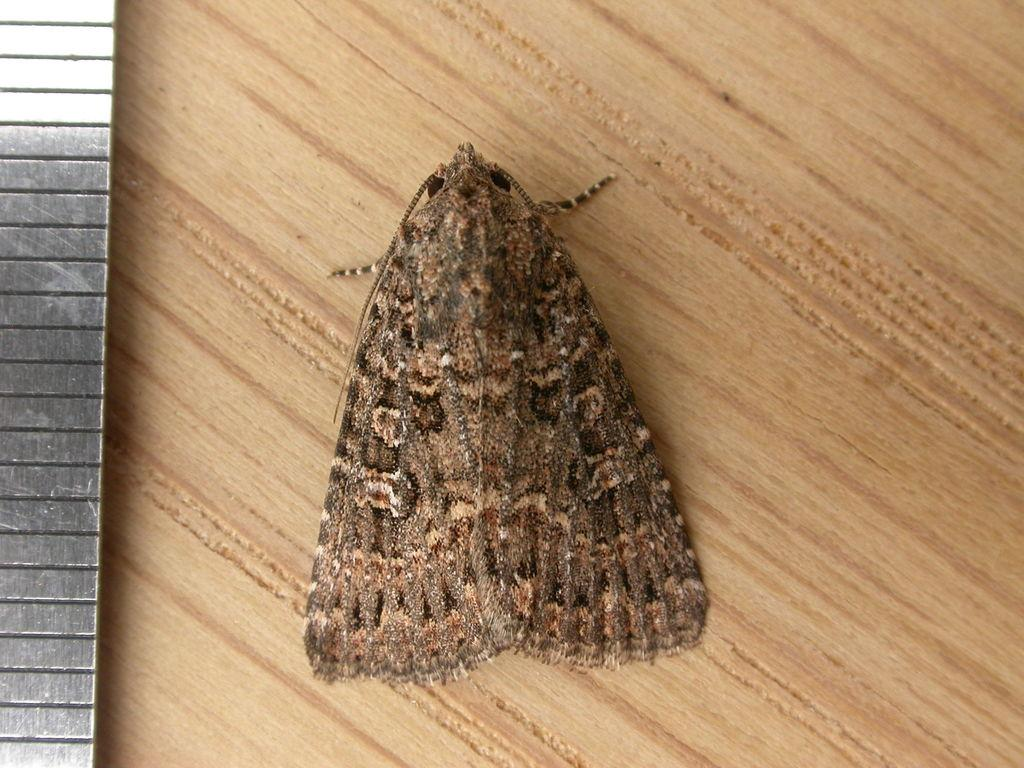What is present in the image? There is a fly in the image. Where is the fly located? The fly is on the wall. What type of sweater is the fly wearing in the image? There is no sweater present in the image, as flies do not wear clothing. 